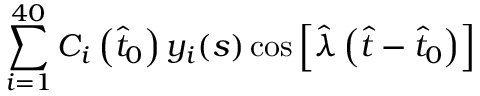Convert formula to latex. <formula><loc_0><loc_0><loc_500><loc_500>\sum _ { i = 1 } ^ { 4 0 } C _ { i } \left ( \hat { t } _ { 0 } \right ) y _ { i } ( s ) \cos \left [ \hat { \lambda } \left ( \hat { t } - \hat { t } _ { 0 } \right ) \right ]</formula> 